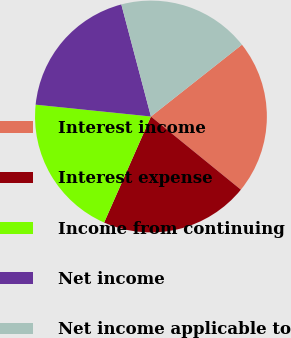Convert chart. <chart><loc_0><loc_0><loc_500><loc_500><pie_chart><fcel>Interest income<fcel>Interest expense<fcel>Income from continuing<fcel>Net income<fcel>Net income applicable to<nl><fcel>21.5%<fcel>20.75%<fcel>20.01%<fcel>19.26%<fcel>18.48%<nl></chart> 